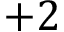Convert formula to latex. <formula><loc_0><loc_0><loc_500><loc_500>+ 2</formula> 